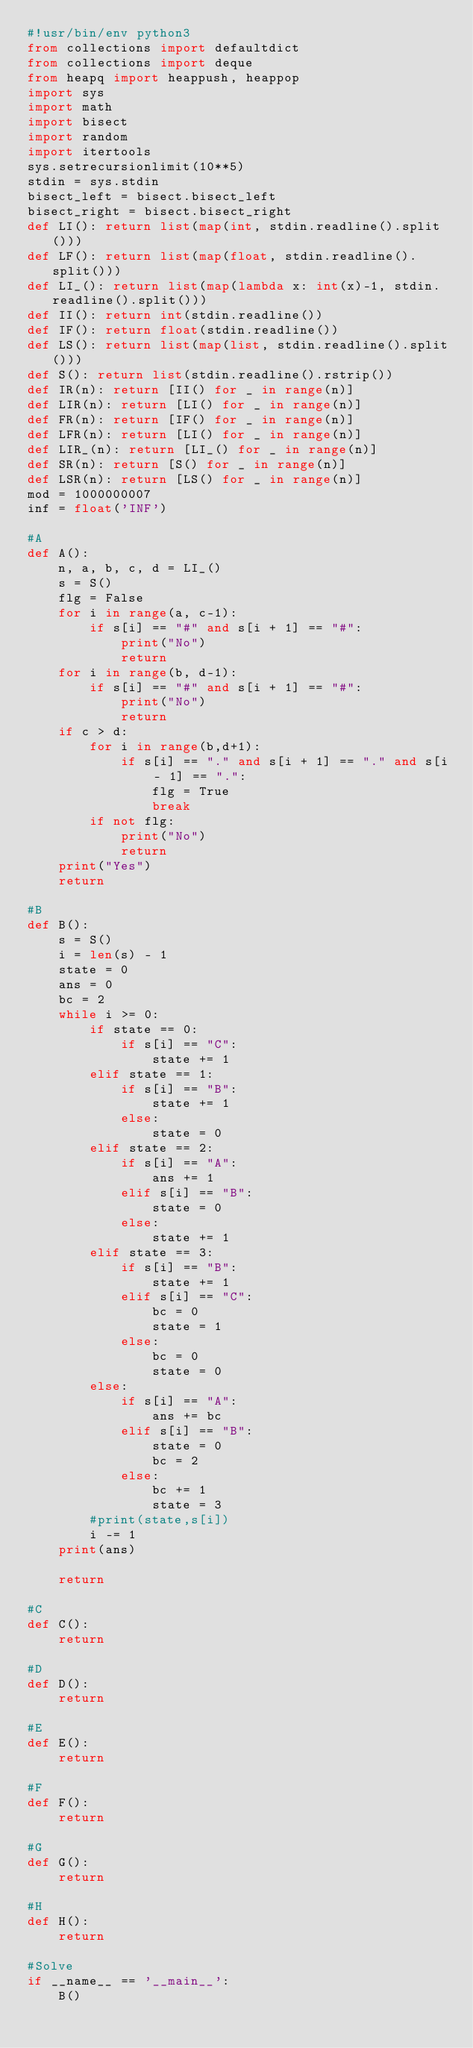<code> <loc_0><loc_0><loc_500><loc_500><_Python_>#!usr/bin/env python3
from collections import defaultdict
from collections import deque
from heapq import heappush, heappop
import sys
import math
import bisect
import random
import itertools
sys.setrecursionlimit(10**5)
stdin = sys.stdin
bisect_left = bisect.bisect_left
bisect_right = bisect.bisect_right
def LI(): return list(map(int, stdin.readline().split()))
def LF(): return list(map(float, stdin.readline().split()))
def LI_(): return list(map(lambda x: int(x)-1, stdin.readline().split()))
def II(): return int(stdin.readline())
def IF(): return float(stdin.readline())
def LS(): return list(map(list, stdin.readline().split()))
def S(): return list(stdin.readline().rstrip())
def IR(n): return [II() for _ in range(n)]
def LIR(n): return [LI() for _ in range(n)]
def FR(n): return [IF() for _ in range(n)]
def LFR(n): return [LI() for _ in range(n)]
def LIR_(n): return [LI_() for _ in range(n)]
def SR(n): return [S() for _ in range(n)]
def LSR(n): return [LS() for _ in range(n)]
mod = 1000000007
inf = float('INF')

#A
def A():
    n, a, b, c, d = LI_()
    s = S()
    flg = False
    for i in range(a, c-1):
        if s[i] == "#" and s[i + 1] == "#":
            print("No")
            return
    for i in range(b, d-1):
        if s[i] == "#" and s[i + 1] == "#":
            print("No")
            return
    if c > d:
        for i in range(b,d+1):
            if s[i] == "." and s[i + 1] == "." and s[i - 1] == ".":
                flg = True
                break
        if not flg:
            print("No")
            return
    print("Yes")
    return

#B
def B():
    s = S()
    i = len(s) - 1
    state = 0
    ans = 0
    bc = 2
    while i >= 0:
        if state == 0:
            if s[i] == "C":
                state += 1
        elif state == 1:
            if s[i] == "B":
                state += 1
            else:
                state = 0
        elif state == 2:
            if s[i] == "A":
                ans += 1
            elif s[i] == "B":
                state = 0
            else:
                state += 1
        elif state == 3:
            if s[i] == "B":
                state += 1
            elif s[i] == "C":
                bc = 0
                state = 1
            else:
                bc = 0
                state = 0
        else:
            if s[i] == "A":
                ans += bc
            elif s[i] == "B":
                state = 0
                bc = 2
            else:
                bc += 1
                state = 3
        #print(state,s[i])
        i -= 1
    print(ans)

    return

#C
def C():
    return

#D
def D():
    return

#E
def E():
    return

#F
def F():
    return

#G
def G():
    return

#H
def H():
    return

#Solve
if __name__ == '__main__':
    B()
</code> 